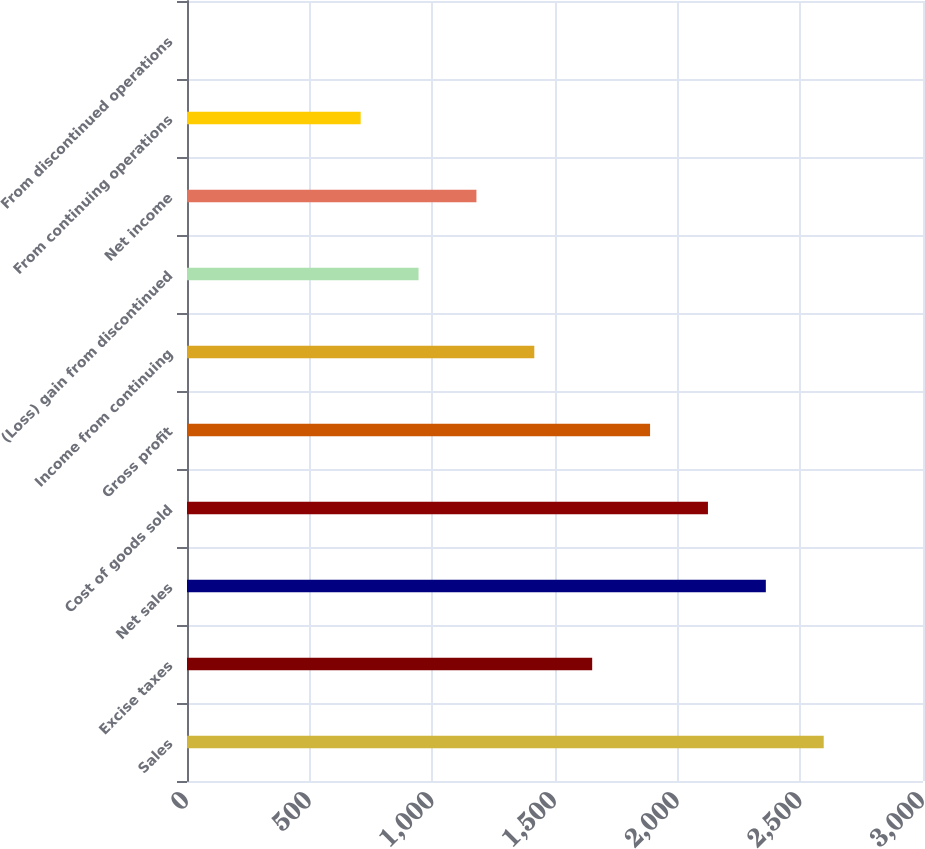<chart> <loc_0><loc_0><loc_500><loc_500><bar_chart><fcel>Sales<fcel>Excise taxes<fcel>Net sales<fcel>Cost of goods sold<fcel>Gross profit<fcel>Income from continuing<fcel>(Loss) gain from discontinued<fcel>Net income<fcel>From continuing operations<fcel>From discontinued operations<nl><fcel>2595.3<fcel>1651.58<fcel>2359.37<fcel>2123.44<fcel>1887.51<fcel>1415.65<fcel>943.79<fcel>1179.72<fcel>707.86<fcel>0.07<nl></chart> 